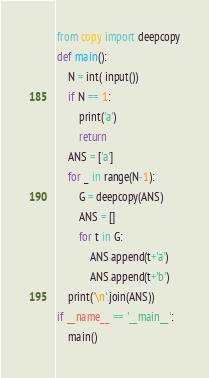<code> <loc_0><loc_0><loc_500><loc_500><_Python_>from copy import deepcopy
def main():
    N = int( input())
    if N == 1:
        print('a')
        return
    ANS = ['a']
    for _ in range(N-1):
        G = deepcopy(ANS)
        ANS = []
        for t in G:
            ANS.append(t+'a')
            ANS.append(t+'b')
    print('\n'.join(ANS))
if __name__ == '__main__':
    main()
</code> 